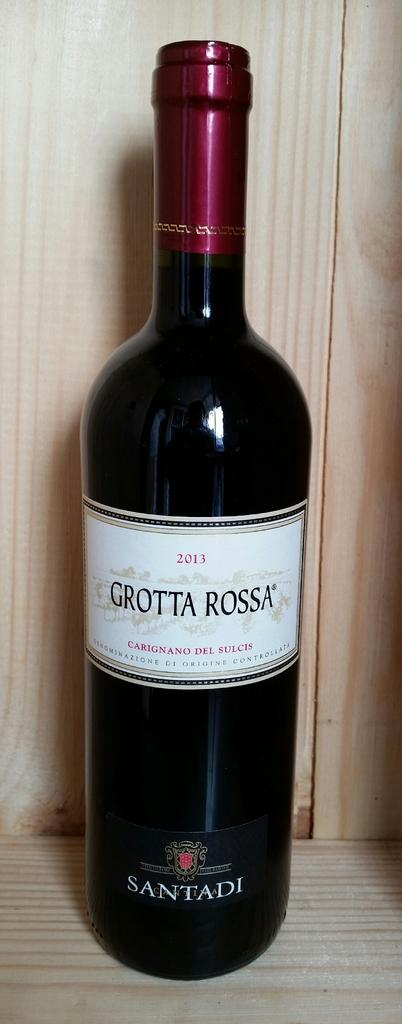<image>
Describe the image concisely. A 2013 bottle of Grotta Rossa wine is displayed on a wooden shelf. 